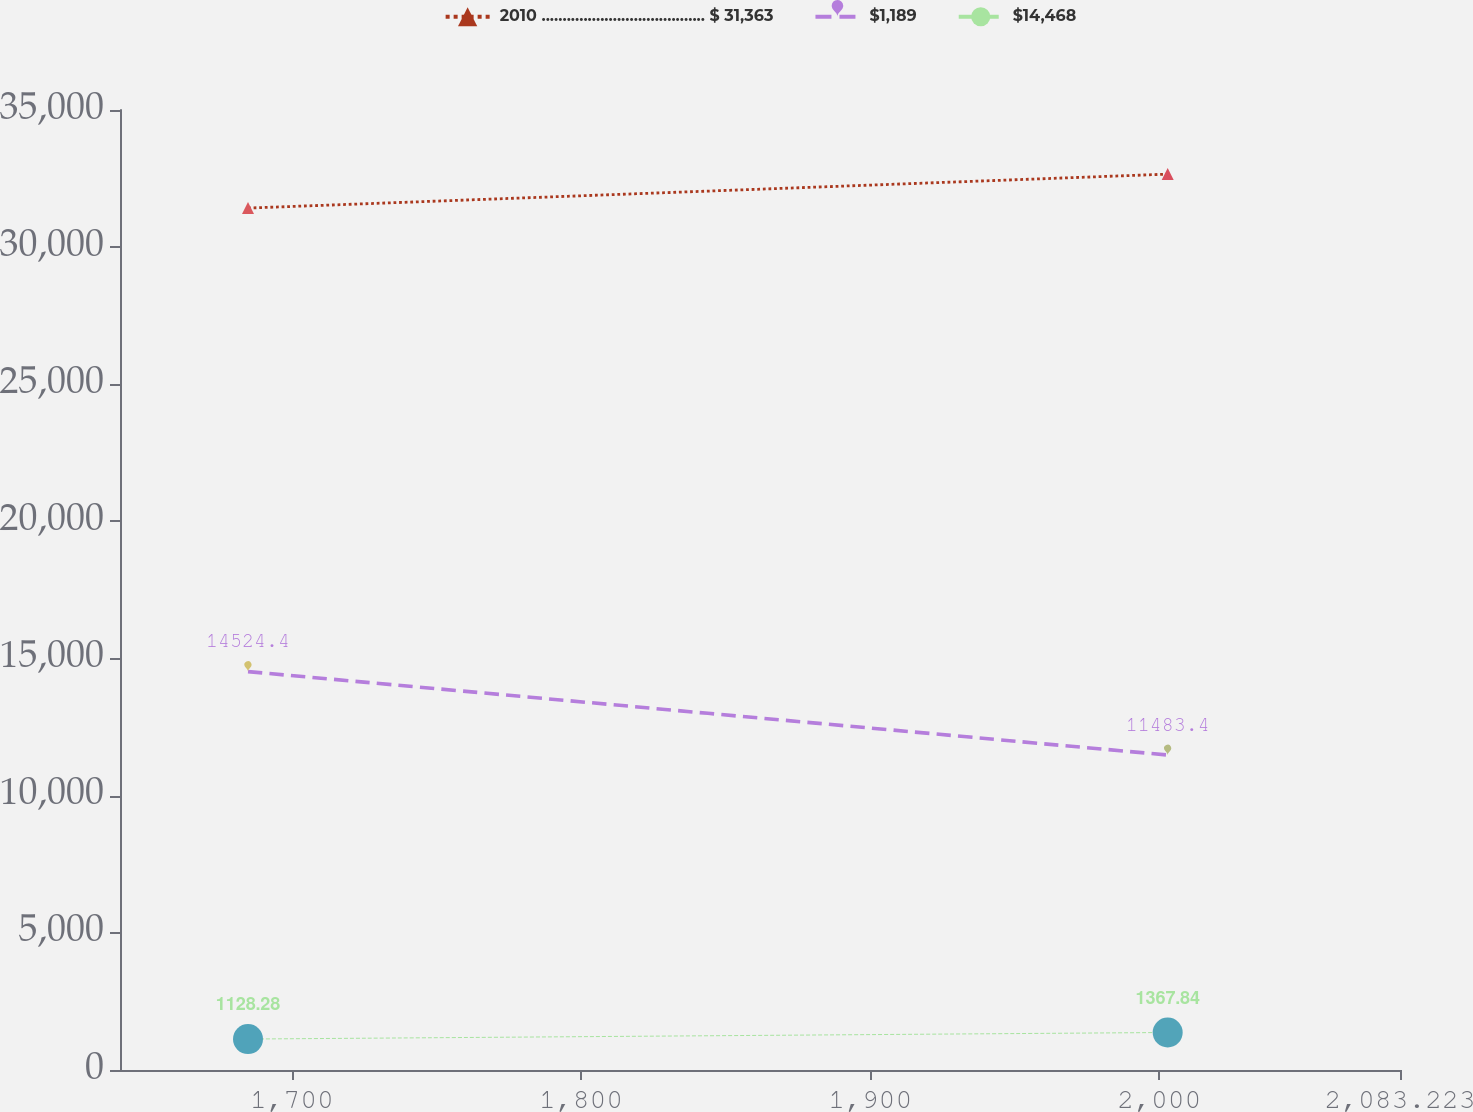<chart> <loc_0><loc_0><loc_500><loc_500><line_chart><ecel><fcel>2010 ....................................... $ 31,363<fcel>$1,189<fcel>$14,468<nl><fcel>1684.82<fcel>31424.1<fcel>14524.4<fcel>1128.28<nl><fcel>2002.88<fcel>32662.2<fcel>11483.4<fcel>1367.84<nl><fcel>2084.33<fcel>31877.5<fcel>10492.9<fcel>1776.28<nl><fcel>2127.49<fcel>32086.3<fcel>4619.63<fcel>1432.64<nl></chart> 